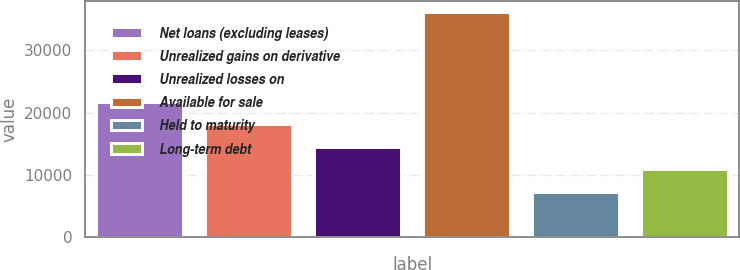<chart> <loc_0><loc_0><loc_500><loc_500><bar_chart><fcel>Net loans (excluding leases)<fcel>Unrealized gains on derivative<fcel>Unrealized losses on<fcel>Available for sale<fcel>Held to maturity<fcel>Long-term debt<nl><fcel>21733<fcel>18123.5<fcel>14514<fcel>36171<fcel>7295<fcel>10904.5<nl></chart> 